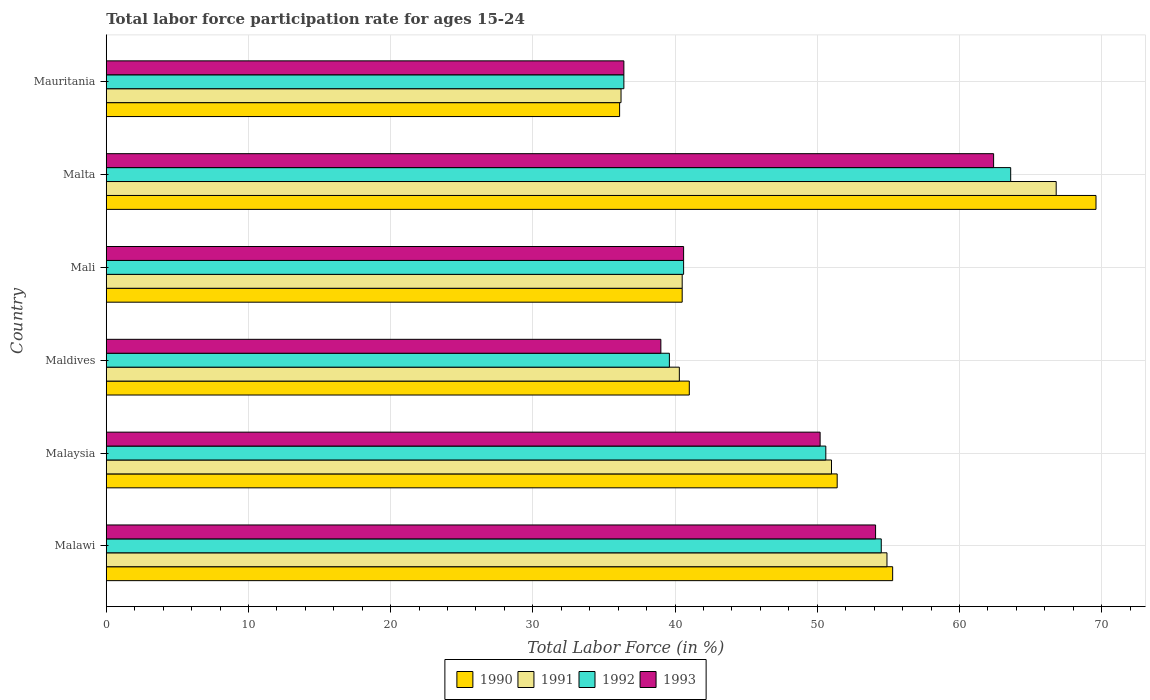How many groups of bars are there?
Give a very brief answer. 6. Are the number of bars on each tick of the Y-axis equal?
Make the answer very short. Yes. What is the label of the 3rd group of bars from the top?
Your answer should be very brief. Mali. What is the labor force participation rate in 1991 in Malawi?
Your response must be concise. 54.9. Across all countries, what is the maximum labor force participation rate in 1992?
Offer a very short reply. 63.6. Across all countries, what is the minimum labor force participation rate in 1992?
Offer a very short reply. 36.4. In which country was the labor force participation rate in 1990 maximum?
Your answer should be very brief. Malta. In which country was the labor force participation rate in 1991 minimum?
Provide a short and direct response. Mauritania. What is the total labor force participation rate in 1991 in the graph?
Provide a succinct answer. 289.7. What is the difference between the labor force participation rate in 1991 in Malawi and that in Maldives?
Offer a very short reply. 14.6. What is the difference between the labor force participation rate in 1993 in Mauritania and the labor force participation rate in 1990 in Malawi?
Offer a terse response. -18.9. What is the average labor force participation rate in 1992 per country?
Your answer should be very brief. 47.55. What is the difference between the labor force participation rate in 1993 and labor force participation rate in 1991 in Malaysia?
Provide a succinct answer. -0.8. What is the ratio of the labor force participation rate in 1991 in Malawi to that in Mauritania?
Your response must be concise. 1.52. Is the difference between the labor force participation rate in 1993 in Maldives and Mauritania greater than the difference between the labor force participation rate in 1991 in Maldives and Mauritania?
Keep it short and to the point. No. What is the difference between the highest and the second highest labor force participation rate in 1990?
Your answer should be very brief. 14.3. In how many countries, is the labor force participation rate in 1993 greater than the average labor force participation rate in 1993 taken over all countries?
Your response must be concise. 3. What does the 4th bar from the bottom in Malawi represents?
Make the answer very short. 1993. Are all the bars in the graph horizontal?
Offer a very short reply. Yes. How many countries are there in the graph?
Keep it short and to the point. 6. Does the graph contain grids?
Offer a very short reply. Yes. How many legend labels are there?
Make the answer very short. 4. How are the legend labels stacked?
Your answer should be compact. Horizontal. What is the title of the graph?
Your answer should be compact. Total labor force participation rate for ages 15-24. What is the label or title of the Y-axis?
Ensure brevity in your answer.  Country. What is the Total Labor Force (in %) of 1990 in Malawi?
Your response must be concise. 55.3. What is the Total Labor Force (in %) in 1991 in Malawi?
Your response must be concise. 54.9. What is the Total Labor Force (in %) in 1992 in Malawi?
Your answer should be compact. 54.5. What is the Total Labor Force (in %) of 1993 in Malawi?
Keep it short and to the point. 54.1. What is the Total Labor Force (in %) of 1990 in Malaysia?
Your answer should be very brief. 51.4. What is the Total Labor Force (in %) of 1992 in Malaysia?
Your answer should be very brief. 50.6. What is the Total Labor Force (in %) in 1993 in Malaysia?
Provide a succinct answer. 50.2. What is the Total Labor Force (in %) in 1990 in Maldives?
Ensure brevity in your answer.  41. What is the Total Labor Force (in %) of 1991 in Maldives?
Offer a terse response. 40.3. What is the Total Labor Force (in %) in 1992 in Maldives?
Provide a succinct answer. 39.6. What is the Total Labor Force (in %) in 1990 in Mali?
Give a very brief answer. 40.5. What is the Total Labor Force (in %) of 1991 in Mali?
Your response must be concise. 40.5. What is the Total Labor Force (in %) of 1992 in Mali?
Provide a succinct answer. 40.6. What is the Total Labor Force (in %) in 1993 in Mali?
Give a very brief answer. 40.6. What is the Total Labor Force (in %) in 1990 in Malta?
Your answer should be compact. 69.6. What is the Total Labor Force (in %) in 1991 in Malta?
Make the answer very short. 66.8. What is the Total Labor Force (in %) of 1992 in Malta?
Provide a succinct answer. 63.6. What is the Total Labor Force (in %) of 1993 in Malta?
Give a very brief answer. 62.4. What is the Total Labor Force (in %) in 1990 in Mauritania?
Keep it short and to the point. 36.1. What is the Total Labor Force (in %) of 1991 in Mauritania?
Give a very brief answer. 36.2. What is the Total Labor Force (in %) in 1992 in Mauritania?
Make the answer very short. 36.4. What is the Total Labor Force (in %) of 1993 in Mauritania?
Keep it short and to the point. 36.4. Across all countries, what is the maximum Total Labor Force (in %) in 1990?
Your answer should be very brief. 69.6. Across all countries, what is the maximum Total Labor Force (in %) of 1991?
Your answer should be compact. 66.8. Across all countries, what is the maximum Total Labor Force (in %) of 1992?
Your response must be concise. 63.6. Across all countries, what is the maximum Total Labor Force (in %) of 1993?
Your answer should be compact. 62.4. Across all countries, what is the minimum Total Labor Force (in %) in 1990?
Ensure brevity in your answer.  36.1. Across all countries, what is the minimum Total Labor Force (in %) of 1991?
Keep it short and to the point. 36.2. Across all countries, what is the minimum Total Labor Force (in %) of 1992?
Your response must be concise. 36.4. Across all countries, what is the minimum Total Labor Force (in %) in 1993?
Your answer should be compact. 36.4. What is the total Total Labor Force (in %) of 1990 in the graph?
Offer a terse response. 293.9. What is the total Total Labor Force (in %) of 1991 in the graph?
Offer a terse response. 289.7. What is the total Total Labor Force (in %) in 1992 in the graph?
Make the answer very short. 285.3. What is the total Total Labor Force (in %) in 1993 in the graph?
Offer a terse response. 282.7. What is the difference between the Total Labor Force (in %) of 1990 in Malawi and that in Malaysia?
Ensure brevity in your answer.  3.9. What is the difference between the Total Labor Force (in %) of 1992 in Malawi and that in Malaysia?
Offer a very short reply. 3.9. What is the difference between the Total Labor Force (in %) of 1993 in Malawi and that in Malaysia?
Keep it short and to the point. 3.9. What is the difference between the Total Labor Force (in %) of 1990 in Malawi and that in Maldives?
Make the answer very short. 14.3. What is the difference between the Total Labor Force (in %) in 1992 in Malawi and that in Maldives?
Provide a short and direct response. 14.9. What is the difference between the Total Labor Force (in %) in 1993 in Malawi and that in Maldives?
Provide a succinct answer. 15.1. What is the difference between the Total Labor Force (in %) of 1992 in Malawi and that in Mali?
Your response must be concise. 13.9. What is the difference between the Total Labor Force (in %) of 1993 in Malawi and that in Mali?
Your response must be concise. 13.5. What is the difference between the Total Labor Force (in %) of 1990 in Malawi and that in Malta?
Your answer should be very brief. -14.3. What is the difference between the Total Labor Force (in %) of 1991 in Malawi and that in Malta?
Give a very brief answer. -11.9. What is the difference between the Total Labor Force (in %) of 1992 in Malawi and that in Malta?
Provide a short and direct response. -9.1. What is the difference between the Total Labor Force (in %) of 1991 in Malawi and that in Mauritania?
Your answer should be compact. 18.7. What is the difference between the Total Labor Force (in %) in 1992 in Malawi and that in Mauritania?
Provide a short and direct response. 18.1. What is the difference between the Total Labor Force (in %) of 1993 in Malaysia and that in Maldives?
Make the answer very short. 11.2. What is the difference between the Total Labor Force (in %) of 1990 in Malaysia and that in Mali?
Ensure brevity in your answer.  10.9. What is the difference between the Total Labor Force (in %) of 1991 in Malaysia and that in Mali?
Ensure brevity in your answer.  10.5. What is the difference between the Total Labor Force (in %) in 1990 in Malaysia and that in Malta?
Your answer should be compact. -18.2. What is the difference between the Total Labor Force (in %) of 1991 in Malaysia and that in Malta?
Ensure brevity in your answer.  -15.8. What is the difference between the Total Labor Force (in %) of 1992 in Malaysia and that in Malta?
Keep it short and to the point. -13. What is the difference between the Total Labor Force (in %) in 1992 in Malaysia and that in Mauritania?
Your response must be concise. 14.2. What is the difference between the Total Labor Force (in %) of 1992 in Maldives and that in Mali?
Keep it short and to the point. -1. What is the difference between the Total Labor Force (in %) of 1990 in Maldives and that in Malta?
Ensure brevity in your answer.  -28.6. What is the difference between the Total Labor Force (in %) in 1991 in Maldives and that in Malta?
Provide a succinct answer. -26.5. What is the difference between the Total Labor Force (in %) in 1992 in Maldives and that in Malta?
Offer a very short reply. -24. What is the difference between the Total Labor Force (in %) of 1993 in Maldives and that in Malta?
Provide a short and direct response. -23.4. What is the difference between the Total Labor Force (in %) of 1991 in Maldives and that in Mauritania?
Ensure brevity in your answer.  4.1. What is the difference between the Total Labor Force (in %) in 1993 in Maldives and that in Mauritania?
Give a very brief answer. 2.6. What is the difference between the Total Labor Force (in %) in 1990 in Mali and that in Malta?
Your answer should be compact. -29.1. What is the difference between the Total Labor Force (in %) of 1991 in Mali and that in Malta?
Your answer should be compact. -26.3. What is the difference between the Total Labor Force (in %) in 1993 in Mali and that in Malta?
Provide a short and direct response. -21.8. What is the difference between the Total Labor Force (in %) of 1993 in Mali and that in Mauritania?
Provide a short and direct response. 4.2. What is the difference between the Total Labor Force (in %) in 1990 in Malta and that in Mauritania?
Your answer should be very brief. 33.5. What is the difference between the Total Labor Force (in %) of 1991 in Malta and that in Mauritania?
Give a very brief answer. 30.6. What is the difference between the Total Labor Force (in %) of 1992 in Malta and that in Mauritania?
Give a very brief answer. 27.2. What is the difference between the Total Labor Force (in %) in 1990 in Malawi and the Total Labor Force (in %) in 1992 in Malaysia?
Your answer should be very brief. 4.7. What is the difference between the Total Labor Force (in %) of 1991 in Malawi and the Total Labor Force (in %) of 1992 in Malaysia?
Your answer should be very brief. 4.3. What is the difference between the Total Labor Force (in %) in 1992 in Malawi and the Total Labor Force (in %) in 1993 in Malaysia?
Make the answer very short. 4.3. What is the difference between the Total Labor Force (in %) in 1990 in Malawi and the Total Labor Force (in %) in 1992 in Maldives?
Give a very brief answer. 15.7. What is the difference between the Total Labor Force (in %) in 1990 in Malawi and the Total Labor Force (in %) in 1993 in Maldives?
Your response must be concise. 16.3. What is the difference between the Total Labor Force (in %) in 1992 in Malawi and the Total Labor Force (in %) in 1993 in Maldives?
Give a very brief answer. 15.5. What is the difference between the Total Labor Force (in %) in 1990 in Malawi and the Total Labor Force (in %) in 1992 in Mali?
Make the answer very short. 14.7. What is the difference between the Total Labor Force (in %) of 1992 in Malawi and the Total Labor Force (in %) of 1993 in Mali?
Offer a terse response. 13.9. What is the difference between the Total Labor Force (in %) in 1990 in Malawi and the Total Labor Force (in %) in 1992 in Malta?
Keep it short and to the point. -8.3. What is the difference between the Total Labor Force (in %) in 1991 in Malawi and the Total Labor Force (in %) in 1992 in Malta?
Give a very brief answer. -8.7. What is the difference between the Total Labor Force (in %) of 1991 in Malawi and the Total Labor Force (in %) of 1993 in Malta?
Provide a short and direct response. -7.5. What is the difference between the Total Labor Force (in %) of 1990 in Malawi and the Total Labor Force (in %) of 1991 in Mauritania?
Give a very brief answer. 19.1. What is the difference between the Total Labor Force (in %) in 1991 in Malawi and the Total Labor Force (in %) in 1992 in Mauritania?
Provide a succinct answer. 18.5. What is the difference between the Total Labor Force (in %) of 1990 in Malaysia and the Total Labor Force (in %) of 1991 in Maldives?
Offer a terse response. 11.1. What is the difference between the Total Labor Force (in %) in 1990 in Malaysia and the Total Labor Force (in %) in 1992 in Maldives?
Your answer should be compact. 11.8. What is the difference between the Total Labor Force (in %) of 1990 in Malaysia and the Total Labor Force (in %) of 1993 in Maldives?
Ensure brevity in your answer.  12.4. What is the difference between the Total Labor Force (in %) in 1991 in Malaysia and the Total Labor Force (in %) in 1993 in Maldives?
Provide a short and direct response. 12. What is the difference between the Total Labor Force (in %) in 1992 in Malaysia and the Total Labor Force (in %) in 1993 in Maldives?
Provide a short and direct response. 11.6. What is the difference between the Total Labor Force (in %) in 1991 in Malaysia and the Total Labor Force (in %) in 1992 in Mali?
Make the answer very short. 10.4. What is the difference between the Total Labor Force (in %) in 1991 in Malaysia and the Total Labor Force (in %) in 1993 in Mali?
Give a very brief answer. 10.4. What is the difference between the Total Labor Force (in %) in 1992 in Malaysia and the Total Labor Force (in %) in 1993 in Mali?
Keep it short and to the point. 10. What is the difference between the Total Labor Force (in %) of 1990 in Malaysia and the Total Labor Force (in %) of 1991 in Malta?
Ensure brevity in your answer.  -15.4. What is the difference between the Total Labor Force (in %) in 1990 in Malaysia and the Total Labor Force (in %) in 1993 in Malta?
Your response must be concise. -11. What is the difference between the Total Labor Force (in %) of 1991 in Malaysia and the Total Labor Force (in %) of 1993 in Malta?
Provide a succinct answer. -11.4. What is the difference between the Total Labor Force (in %) of 1990 in Malaysia and the Total Labor Force (in %) of 1991 in Mauritania?
Your response must be concise. 15.2. What is the difference between the Total Labor Force (in %) of 1991 in Malaysia and the Total Labor Force (in %) of 1992 in Mauritania?
Your answer should be very brief. 14.6. What is the difference between the Total Labor Force (in %) of 1990 in Maldives and the Total Labor Force (in %) of 1991 in Mali?
Ensure brevity in your answer.  0.5. What is the difference between the Total Labor Force (in %) of 1990 in Maldives and the Total Labor Force (in %) of 1993 in Mali?
Give a very brief answer. 0.4. What is the difference between the Total Labor Force (in %) of 1991 in Maldives and the Total Labor Force (in %) of 1993 in Mali?
Provide a succinct answer. -0.3. What is the difference between the Total Labor Force (in %) of 1990 in Maldives and the Total Labor Force (in %) of 1991 in Malta?
Offer a very short reply. -25.8. What is the difference between the Total Labor Force (in %) in 1990 in Maldives and the Total Labor Force (in %) in 1992 in Malta?
Provide a succinct answer. -22.6. What is the difference between the Total Labor Force (in %) of 1990 in Maldives and the Total Labor Force (in %) of 1993 in Malta?
Give a very brief answer. -21.4. What is the difference between the Total Labor Force (in %) in 1991 in Maldives and the Total Labor Force (in %) in 1992 in Malta?
Provide a short and direct response. -23.3. What is the difference between the Total Labor Force (in %) of 1991 in Maldives and the Total Labor Force (in %) of 1993 in Malta?
Offer a terse response. -22.1. What is the difference between the Total Labor Force (in %) of 1992 in Maldives and the Total Labor Force (in %) of 1993 in Malta?
Your answer should be very brief. -22.8. What is the difference between the Total Labor Force (in %) in 1990 in Maldives and the Total Labor Force (in %) in 1992 in Mauritania?
Give a very brief answer. 4.6. What is the difference between the Total Labor Force (in %) in 1990 in Maldives and the Total Labor Force (in %) in 1993 in Mauritania?
Offer a terse response. 4.6. What is the difference between the Total Labor Force (in %) in 1991 in Maldives and the Total Labor Force (in %) in 1993 in Mauritania?
Offer a terse response. 3.9. What is the difference between the Total Labor Force (in %) of 1990 in Mali and the Total Labor Force (in %) of 1991 in Malta?
Ensure brevity in your answer.  -26.3. What is the difference between the Total Labor Force (in %) of 1990 in Mali and the Total Labor Force (in %) of 1992 in Malta?
Make the answer very short. -23.1. What is the difference between the Total Labor Force (in %) of 1990 in Mali and the Total Labor Force (in %) of 1993 in Malta?
Offer a terse response. -21.9. What is the difference between the Total Labor Force (in %) in 1991 in Mali and the Total Labor Force (in %) in 1992 in Malta?
Ensure brevity in your answer.  -23.1. What is the difference between the Total Labor Force (in %) of 1991 in Mali and the Total Labor Force (in %) of 1993 in Malta?
Keep it short and to the point. -21.9. What is the difference between the Total Labor Force (in %) of 1992 in Mali and the Total Labor Force (in %) of 1993 in Malta?
Offer a very short reply. -21.8. What is the difference between the Total Labor Force (in %) of 1990 in Mali and the Total Labor Force (in %) of 1991 in Mauritania?
Offer a terse response. 4.3. What is the difference between the Total Labor Force (in %) of 1990 in Mali and the Total Labor Force (in %) of 1993 in Mauritania?
Provide a short and direct response. 4.1. What is the difference between the Total Labor Force (in %) of 1991 in Mali and the Total Labor Force (in %) of 1993 in Mauritania?
Offer a terse response. 4.1. What is the difference between the Total Labor Force (in %) of 1992 in Mali and the Total Labor Force (in %) of 1993 in Mauritania?
Offer a very short reply. 4.2. What is the difference between the Total Labor Force (in %) of 1990 in Malta and the Total Labor Force (in %) of 1991 in Mauritania?
Offer a very short reply. 33.4. What is the difference between the Total Labor Force (in %) in 1990 in Malta and the Total Labor Force (in %) in 1992 in Mauritania?
Provide a short and direct response. 33.2. What is the difference between the Total Labor Force (in %) of 1990 in Malta and the Total Labor Force (in %) of 1993 in Mauritania?
Give a very brief answer. 33.2. What is the difference between the Total Labor Force (in %) in 1991 in Malta and the Total Labor Force (in %) in 1992 in Mauritania?
Offer a very short reply. 30.4. What is the difference between the Total Labor Force (in %) of 1991 in Malta and the Total Labor Force (in %) of 1993 in Mauritania?
Your answer should be compact. 30.4. What is the difference between the Total Labor Force (in %) of 1992 in Malta and the Total Labor Force (in %) of 1993 in Mauritania?
Keep it short and to the point. 27.2. What is the average Total Labor Force (in %) of 1990 per country?
Offer a terse response. 48.98. What is the average Total Labor Force (in %) of 1991 per country?
Ensure brevity in your answer.  48.28. What is the average Total Labor Force (in %) of 1992 per country?
Provide a short and direct response. 47.55. What is the average Total Labor Force (in %) of 1993 per country?
Your answer should be compact. 47.12. What is the difference between the Total Labor Force (in %) in 1990 and Total Labor Force (in %) in 1991 in Malawi?
Offer a terse response. 0.4. What is the difference between the Total Labor Force (in %) in 1991 and Total Labor Force (in %) in 1992 in Malawi?
Your response must be concise. 0.4. What is the difference between the Total Labor Force (in %) of 1991 and Total Labor Force (in %) of 1993 in Malawi?
Make the answer very short. 0.8. What is the difference between the Total Labor Force (in %) of 1992 and Total Labor Force (in %) of 1993 in Malawi?
Keep it short and to the point. 0.4. What is the difference between the Total Labor Force (in %) in 1990 and Total Labor Force (in %) in 1992 in Malaysia?
Provide a short and direct response. 0.8. What is the difference between the Total Labor Force (in %) in 1990 and Total Labor Force (in %) in 1993 in Malaysia?
Make the answer very short. 1.2. What is the difference between the Total Labor Force (in %) in 1990 and Total Labor Force (in %) in 1991 in Maldives?
Provide a short and direct response. 0.7. What is the difference between the Total Labor Force (in %) in 1990 and Total Labor Force (in %) in 1992 in Maldives?
Ensure brevity in your answer.  1.4. What is the difference between the Total Labor Force (in %) in 1990 and Total Labor Force (in %) in 1993 in Maldives?
Offer a terse response. 2. What is the difference between the Total Labor Force (in %) in 1991 and Total Labor Force (in %) in 1992 in Maldives?
Make the answer very short. 0.7. What is the difference between the Total Labor Force (in %) of 1992 and Total Labor Force (in %) of 1993 in Maldives?
Offer a very short reply. 0.6. What is the difference between the Total Labor Force (in %) of 1990 and Total Labor Force (in %) of 1992 in Mali?
Provide a short and direct response. -0.1. What is the difference between the Total Labor Force (in %) in 1991 and Total Labor Force (in %) in 1992 in Mali?
Provide a succinct answer. -0.1. What is the difference between the Total Labor Force (in %) of 1990 and Total Labor Force (in %) of 1993 in Malta?
Make the answer very short. 7.2. What is the difference between the Total Labor Force (in %) of 1991 and Total Labor Force (in %) of 1992 in Malta?
Offer a terse response. 3.2. What is the difference between the Total Labor Force (in %) in 1991 and Total Labor Force (in %) in 1993 in Malta?
Your answer should be very brief. 4.4. What is the difference between the Total Labor Force (in %) in 1992 and Total Labor Force (in %) in 1993 in Malta?
Provide a succinct answer. 1.2. What is the difference between the Total Labor Force (in %) in 1990 and Total Labor Force (in %) in 1991 in Mauritania?
Make the answer very short. -0.1. What is the difference between the Total Labor Force (in %) of 1990 and Total Labor Force (in %) of 1992 in Mauritania?
Make the answer very short. -0.3. What is the difference between the Total Labor Force (in %) in 1991 and Total Labor Force (in %) in 1992 in Mauritania?
Provide a succinct answer. -0.2. What is the difference between the Total Labor Force (in %) in 1991 and Total Labor Force (in %) in 1993 in Mauritania?
Keep it short and to the point. -0.2. What is the ratio of the Total Labor Force (in %) in 1990 in Malawi to that in Malaysia?
Your response must be concise. 1.08. What is the ratio of the Total Labor Force (in %) in 1991 in Malawi to that in Malaysia?
Your answer should be very brief. 1.08. What is the ratio of the Total Labor Force (in %) in 1992 in Malawi to that in Malaysia?
Offer a very short reply. 1.08. What is the ratio of the Total Labor Force (in %) of 1993 in Malawi to that in Malaysia?
Provide a succinct answer. 1.08. What is the ratio of the Total Labor Force (in %) in 1990 in Malawi to that in Maldives?
Your answer should be very brief. 1.35. What is the ratio of the Total Labor Force (in %) in 1991 in Malawi to that in Maldives?
Your response must be concise. 1.36. What is the ratio of the Total Labor Force (in %) of 1992 in Malawi to that in Maldives?
Provide a short and direct response. 1.38. What is the ratio of the Total Labor Force (in %) in 1993 in Malawi to that in Maldives?
Offer a terse response. 1.39. What is the ratio of the Total Labor Force (in %) of 1990 in Malawi to that in Mali?
Your answer should be compact. 1.37. What is the ratio of the Total Labor Force (in %) in 1991 in Malawi to that in Mali?
Keep it short and to the point. 1.36. What is the ratio of the Total Labor Force (in %) of 1992 in Malawi to that in Mali?
Give a very brief answer. 1.34. What is the ratio of the Total Labor Force (in %) in 1993 in Malawi to that in Mali?
Provide a short and direct response. 1.33. What is the ratio of the Total Labor Force (in %) in 1990 in Malawi to that in Malta?
Your response must be concise. 0.79. What is the ratio of the Total Labor Force (in %) in 1991 in Malawi to that in Malta?
Give a very brief answer. 0.82. What is the ratio of the Total Labor Force (in %) of 1992 in Malawi to that in Malta?
Offer a very short reply. 0.86. What is the ratio of the Total Labor Force (in %) in 1993 in Malawi to that in Malta?
Provide a succinct answer. 0.87. What is the ratio of the Total Labor Force (in %) in 1990 in Malawi to that in Mauritania?
Your answer should be compact. 1.53. What is the ratio of the Total Labor Force (in %) in 1991 in Malawi to that in Mauritania?
Your answer should be compact. 1.52. What is the ratio of the Total Labor Force (in %) of 1992 in Malawi to that in Mauritania?
Provide a short and direct response. 1.5. What is the ratio of the Total Labor Force (in %) of 1993 in Malawi to that in Mauritania?
Offer a very short reply. 1.49. What is the ratio of the Total Labor Force (in %) in 1990 in Malaysia to that in Maldives?
Provide a short and direct response. 1.25. What is the ratio of the Total Labor Force (in %) in 1991 in Malaysia to that in Maldives?
Provide a short and direct response. 1.27. What is the ratio of the Total Labor Force (in %) of 1992 in Malaysia to that in Maldives?
Your answer should be compact. 1.28. What is the ratio of the Total Labor Force (in %) of 1993 in Malaysia to that in Maldives?
Make the answer very short. 1.29. What is the ratio of the Total Labor Force (in %) in 1990 in Malaysia to that in Mali?
Keep it short and to the point. 1.27. What is the ratio of the Total Labor Force (in %) in 1991 in Malaysia to that in Mali?
Give a very brief answer. 1.26. What is the ratio of the Total Labor Force (in %) in 1992 in Malaysia to that in Mali?
Offer a terse response. 1.25. What is the ratio of the Total Labor Force (in %) of 1993 in Malaysia to that in Mali?
Keep it short and to the point. 1.24. What is the ratio of the Total Labor Force (in %) in 1990 in Malaysia to that in Malta?
Give a very brief answer. 0.74. What is the ratio of the Total Labor Force (in %) in 1991 in Malaysia to that in Malta?
Offer a terse response. 0.76. What is the ratio of the Total Labor Force (in %) in 1992 in Malaysia to that in Malta?
Your response must be concise. 0.8. What is the ratio of the Total Labor Force (in %) in 1993 in Malaysia to that in Malta?
Your answer should be very brief. 0.8. What is the ratio of the Total Labor Force (in %) of 1990 in Malaysia to that in Mauritania?
Your answer should be compact. 1.42. What is the ratio of the Total Labor Force (in %) of 1991 in Malaysia to that in Mauritania?
Give a very brief answer. 1.41. What is the ratio of the Total Labor Force (in %) in 1992 in Malaysia to that in Mauritania?
Provide a succinct answer. 1.39. What is the ratio of the Total Labor Force (in %) in 1993 in Malaysia to that in Mauritania?
Offer a terse response. 1.38. What is the ratio of the Total Labor Force (in %) in 1990 in Maldives to that in Mali?
Your response must be concise. 1.01. What is the ratio of the Total Labor Force (in %) in 1992 in Maldives to that in Mali?
Provide a short and direct response. 0.98. What is the ratio of the Total Labor Force (in %) in 1993 in Maldives to that in Mali?
Provide a succinct answer. 0.96. What is the ratio of the Total Labor Force (in %) in 1990 in Maldives to that in Malta?
Ensure brevity in your answer.  0.59. What is the ratio of the Total Labor Force (in %) in 1991 in Maldives to that in Malta?
Offer a very short reply. 0.6. What is the ratio of the Total Labor Force (in %) in 1992 in Maldives to that in Malta?
Your answer should be very brief. 0.62. What is the ratio of the Total Labor Force (in %) in 1990 in Maldives to that in Mauritania?
Offer a terse response. 1.14. What is the ratio of the Total Labor Force (in %) in 1991 in Maldives to that in Mauritania?
Ensure brevity in your answer.  1.11. What is the ratio of the Total Labor Force (in %) in 1992 in Maldives to that in Mauritania?
Ensure brevity in your answer.  1.09. What is the ratio of the Total Labor Force (in %) of 1993 in Maldives to that in Mauritania?
Keep it short and to the point. 1.07. What is the ratio of the Total Labor Force (in %) of 1990 in Mali to that in Malta?
Your answer should be very brief. 0.58. What is the ratio of the Total Labor Force (in %) of 1991 in Mali to that in Malta?
Ensure brevity in your answer.  0.61. What is the ratio of the Total Labor Force (in %) of 1992 in Mali to that in Malta?
Your response must be concise. 0.64. What is the ratio of the Total Labor Force (in %) in 1993 in Mali to that in Malta?
Your answer should be very brief. 0.65. What is the ratio of the Total Labor Force (in %) in 1990 in Mali to that in Mauritania?
Make the answer very short. 1.12. What is the ratio of the Total Labor Force (in %) of 1991 in Mali to that in Mauritania?
Offer a terse response. 1.12. What is the ratio of the Total Labor Force (in %) in 1992 in Mali to that in Mauritania?
Provide a short and direct response. 1.12. What is the ratio of the Total Labor Force (in %) of 1993 in Mali to that in Mauritania?
Your answer should be very brief. 1.12. What is the ratio of the Total Labor Force (in %) in 1990 in Malta to that in Mauritania?
Ensure brevity in your answer.  1.93. What is the ratio of the Total Labor Force (in %) in 1991 in Malta to that in Mauritania?
Give a very brief answer. 1.85. What is the ratio of the Total Labor Force (in %) in 1992 in Malta to that in Mauritania?
Your answer should be very brief. 1.75. What is the ratio of the Total Labor Force (in %) of 1993 in Malta to that in Mauritania?
Your answer should be compact. 1.71. What is the difference between the highest and the second highest Total Labor Force (in %) in 1991?
Make the answer very short. 11.9. What is the difference between the highest and the second highest Total Labor Force (in %) in 1992?
Ensure brevity in your answer.  9.1. What is the difference between the highest and the lowest Total Labor Force (in %) in 1990?
Keep it short and to the point. 33.5. What is the difference between the highest and the lowest Total Labor Force (in %) of 1991?
Keep it short and to the point. 30.6. What is the difference between the highest and the lowest Total Labor Force (in %) of 1992?
Offer a terse response. 27.2. What is the difference between the highest and the lowest Total Labor Force (in %) in 1993?
Provide a short and direct response. 26. 